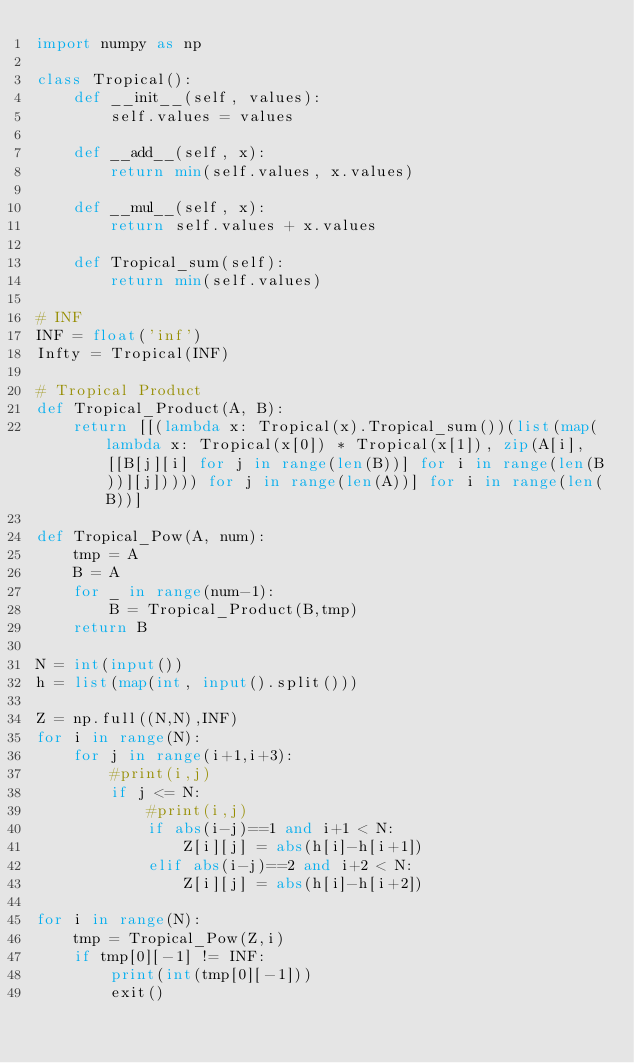Convert code to text. <code><loc_0><loc_0><loc_500><loc_500><_Python_>import numpy as np

class Tropical():
    def __init__(self, values):
        self.values = values

    def __add__(self, x):
        return min(self.values, x.values)

    def __mul__(self, x):
        return self.values + x.values

    def Tropical_sum(self):
        return min(self.values)

# INF
INF = float('inf')
Infty = Tropical(INF)

# Tropical Product
def Tropical_Product(A, B):
    return [[(lambda x: Tropical(x).Tropical_sum())(list(map(lambda x: Tropical(x[0]) * Tropical(x[1]), zip(A[i], [[B[j][i] for j in range(len(B))] for i in range(len(B))][j])))) for j in range(len(A))] for i in range(len(B))]

def Tropical_Pow(A, num):
    tmp = A
    B = A
    for _ in range(num-1):
        B = Tropical_Product(B,tmp)
    return B

N = int(input())
h = list(map(int, input().split()))

Z = np.full((N,N),INF)
for i in range(N):
    for j in range(i+1,i+3):
        #print(i,j)
        if j <= N:
            #print(i,j)
            if abs(i-j)==1 and i+1 < N:
                Z[i][j] = abs(h[i]-h[i+1])
            elif abs(i-j)==2 and i+2 < N:
                Z[i][j] = abs(h[i]-h[i+2])

for i in range(N):
    tmp = Tropical_Pow(Z,i)
    if tmp[0][-1] != INF:
        print(int(tmp[0][-1]))
        exit()</code> 